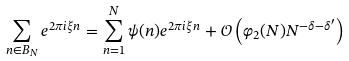<formula> <loc_0><loc_0><loc_500><loc_500>\sum _ { n \in B _ { N } } e ^ { 2 \pi i \xi n } = \sum _ { n = 1 } ^ { N } \psi ( n ) e ^ { 2 \pi i \xi n } + \mathcal { O } \left ( \varphi _ { 2 } ( N ) N ^ { - \delta - \delta ^ { \prime } } \right )</formula> 